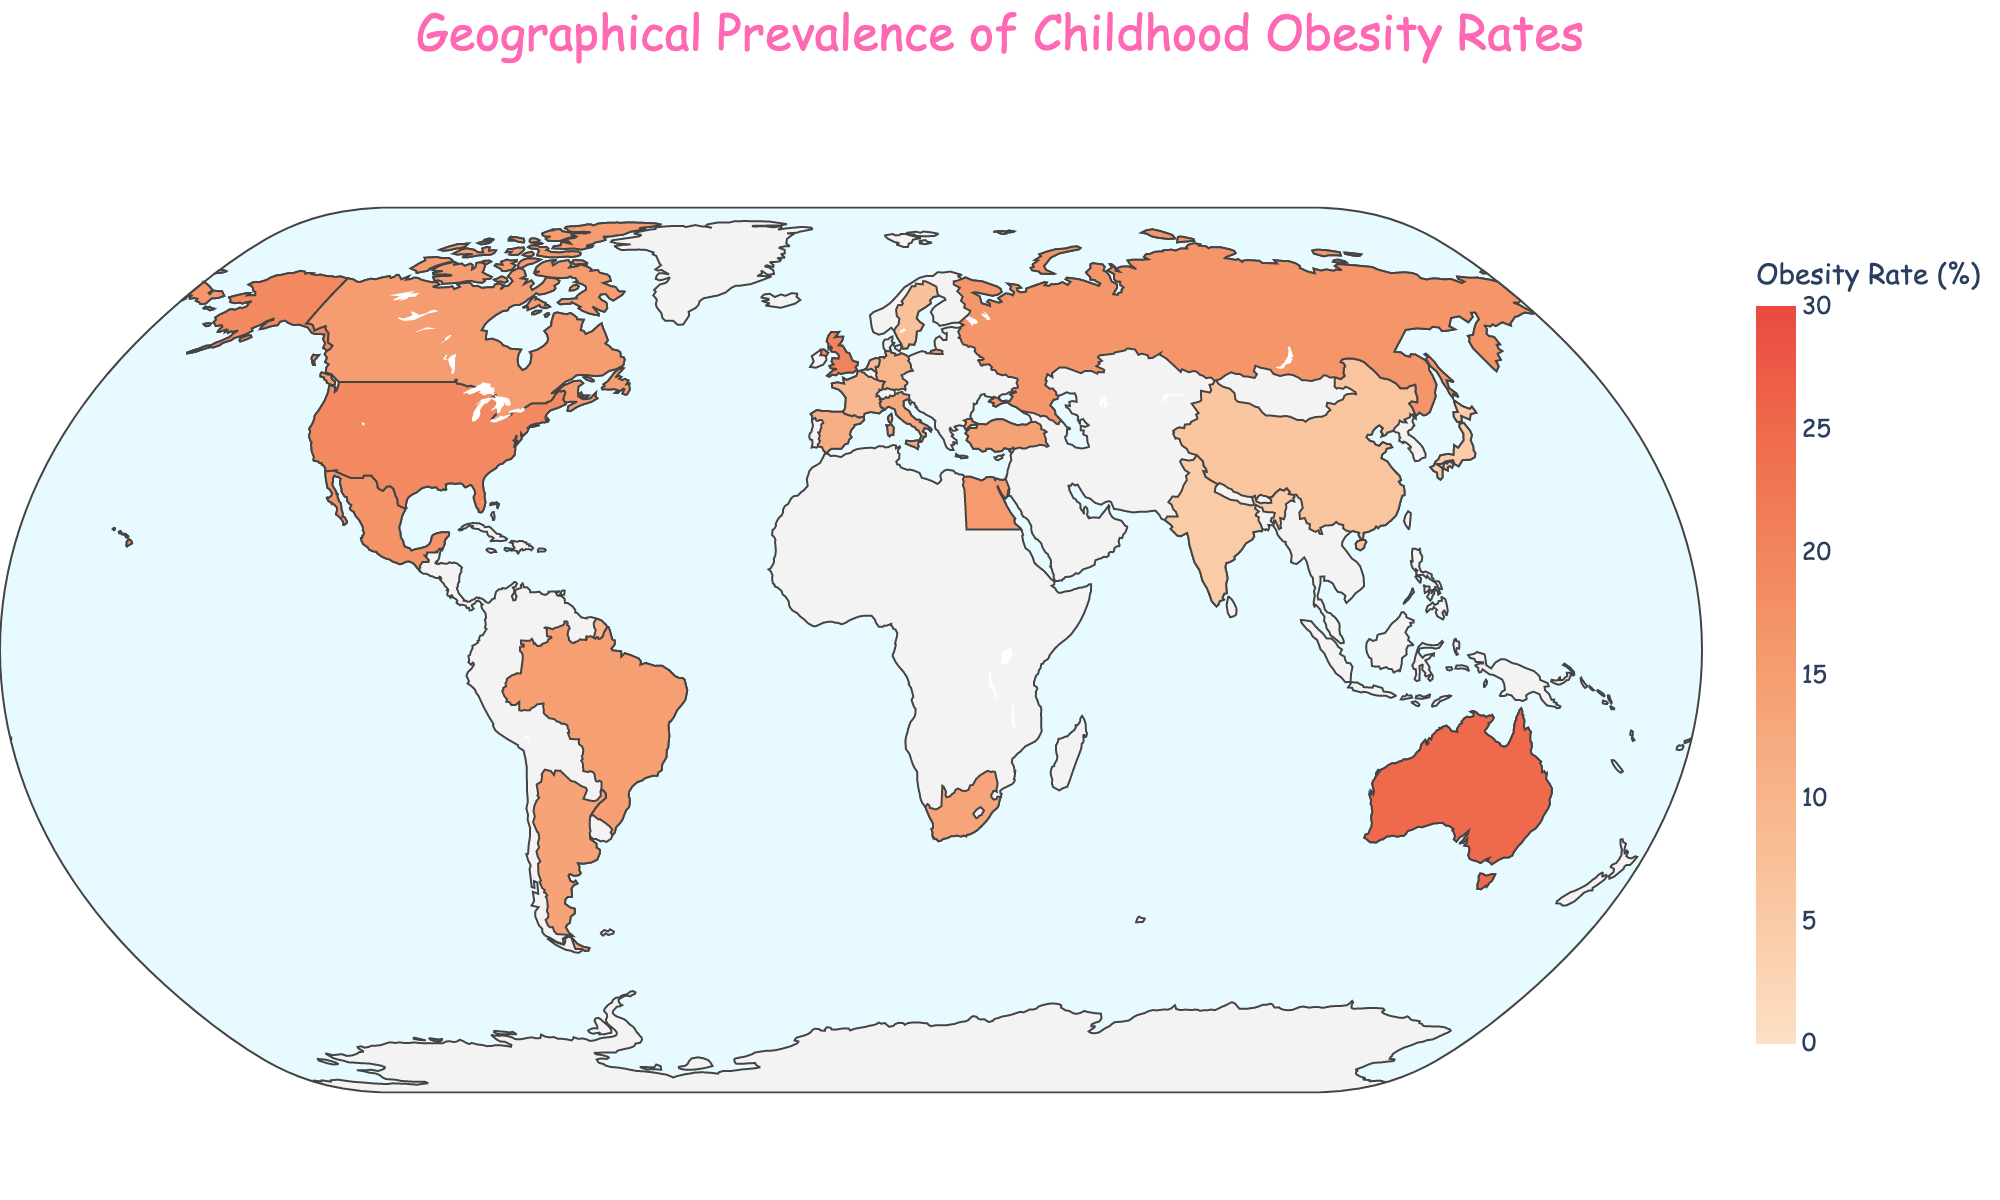What's the title of the figure? The title of the figure is usually positioned at the top of the visual. From the given data, the title of the figure is "Geographical Prevalence of Childhood Obesity Rates".
Answer: Geographical Prevalence of Childhood Obesity Rates Which region has the highest childhood obesity rate? In a choropleth map, regions with the highest values are typically highlighted with the most intense color. Based on the data, Australia has the highest childhood obesity rate at 25.0%.
Answer: Australia Which region has the lowest childhood obesity rate? The region with the least intense coloration (lightest color) represents the lowest rate on a choropleth map. From the data, Japan has the lowest childhood obesity rate at 4.8%.
Answer: Japan What is the obesity rate for the United States? The specific value for a region can be found by either inspecting the figure or consulting the provided data. For the United States, the childhood obesity rate is 19.3%.
Answer: 19.3% Which regions have a childhood obesity rate greater than 20%? To answer this, identify all regions in the data where the obesity rate exceeds 20%. According to the data, the regions are the United Kingdom (20.1%) and Australia (25.0%).
Answer: United Kingdom, Australia What is the range of childhood obesity rates depicted in this figure? The range can be determined by identifying the smallest and largest values in the data. The smallest rate is 4.8% (Japan) and the largest rate is 25.0% (Australia). Therefore, the range is 25.0% - 4.8% = 20.2%.
Answer: 20.2% Which European region has the highest childhood obesity rate? By examining the regions in Europe listed in the data, the one with the highest rate is the United Kingdom, with an obesity rate of 20.1%.
Answer: United Kingdom What is the average childhood obesity rate across all regions shown? To find the average, sum all the obesity rates from the data and divide by the number of regions. The total sum is 258.7% (sum of all values in the data), and there are 19 regions, so the average rate is 258.7% / 19 ≈ 13.62%.
Answer: 13.62% Compare the childhood obesity rates of Mexico and Canada. Which one is higher? By examining the rates for both countries from the data, Mexico has an obesity rate of 17.5%, while Canada has a rate of 15.2%. Therefore, Mexico's rate is higher than Canada's.
Answer: Mexico Which regions have a childhood obesity rate between 10% and 15%? By identifying the regions within the given range from the data, the regions are Germany (10.3%), Spain (11.7%), Italy (12.8%), South Africa (13.5%), Brazil (14.8%), and Turkey (14.2%).
Answer: Germany, Spain, Italy, South Africa, Brazil, Turkey 